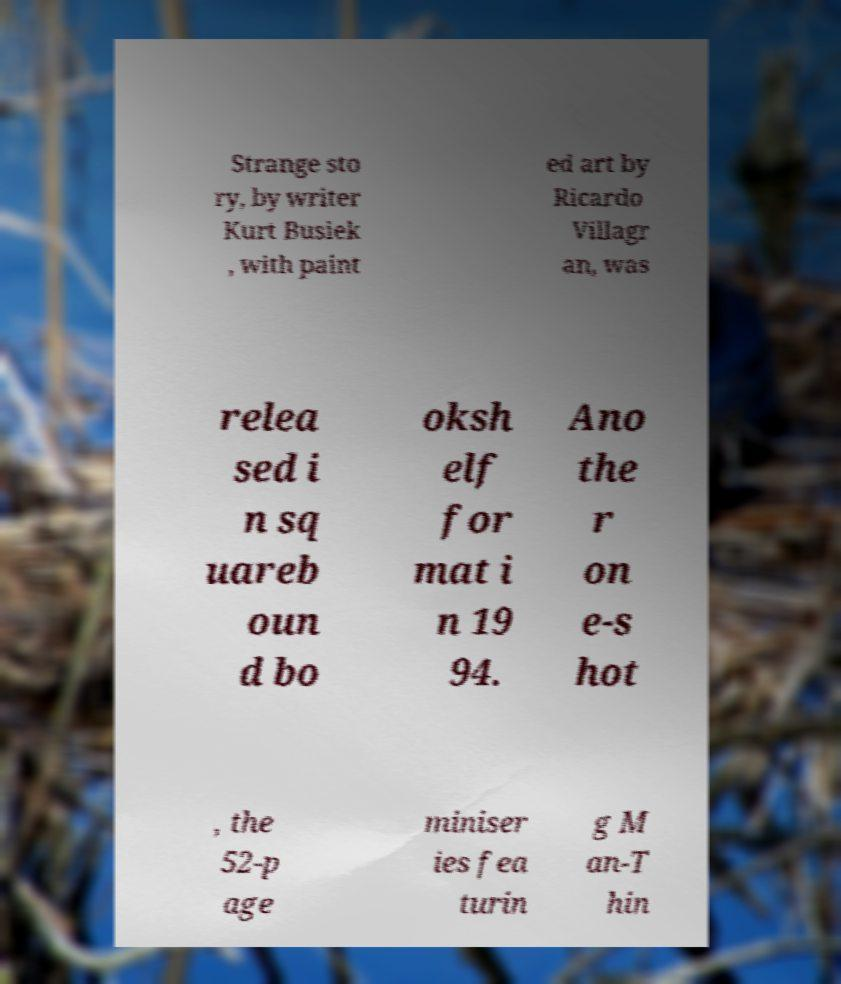I need the written content from this picture converted into text. Can you do that? Strange sto ry, by writer Kurt Busiek , with paint ed art by Ricardo Villagr an, was relea sed i n sq uareb oun d bo oksh elf for mat i n 19 94. Ano the r on e-s hot , the 52-p age miniser ies fea turin g M an-T hin 